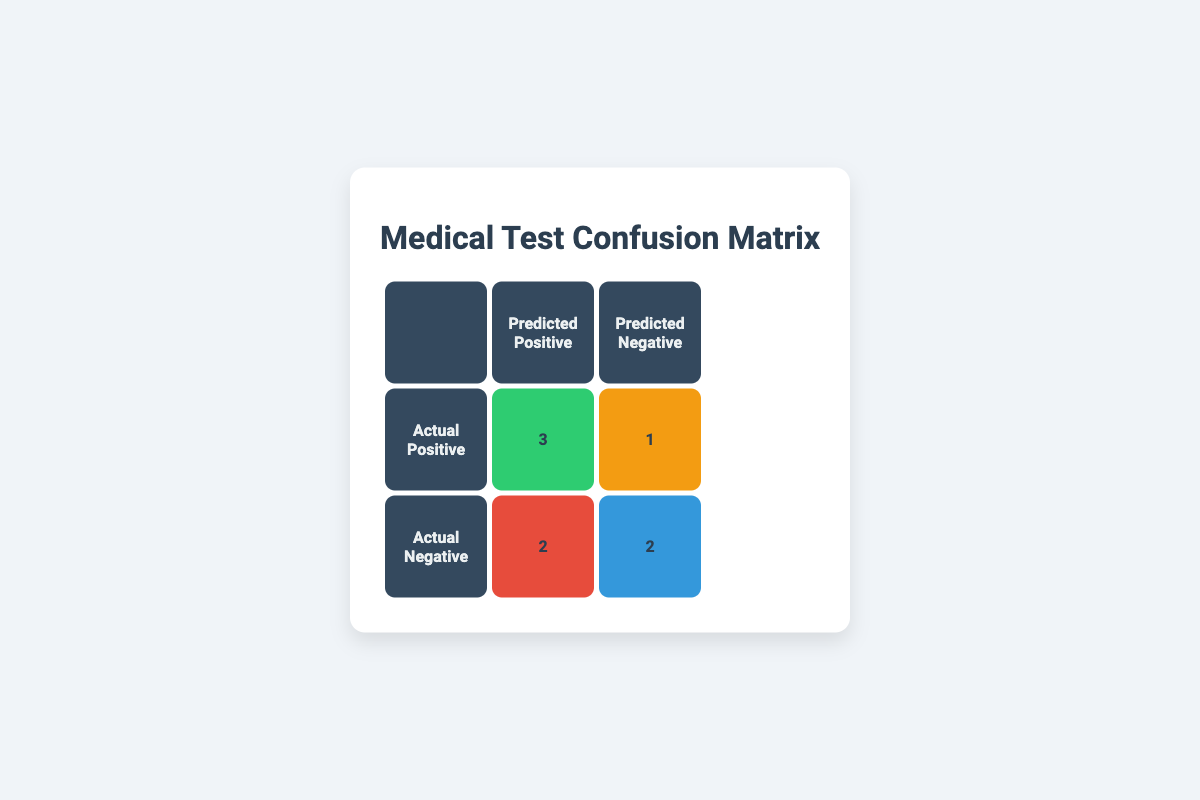What is the number of true positives? The table indicates that the true positives (actual positive and predicted positive) are represented in the first row and first column, which shows the value "3".
Answer: 3 What is the number of false negatives? The false negatives (actual positive and predicted negative) are found in the first row and second column. The value shown here is "1".
Answer: 1 How many total positive test results were predicted by the diagnostic test? The total positive predictions consist of true positives and false positives. From the table, true positives are "3" and false positives are "2". Adding these gives 3 + 2 = 5.
Answer: 5 Is the number of true negatives greater than the number of false positives? The true negatives are indicated in the second row and second column with a value of "2", while the false positives are in the second row and first column with a value of "2". Since 2 is not greater than 2, the answer is no.
Answer: No What is the total number of patients in the study? The total number of patients can be calculated by adding all entries in the matrix. There are 3 true positives, 1 false negative, 2 false positives, and 2 true negatives: 3 + 1 + 2 + 2 = 8.
Answer: 8 If only false positive results were addressed, how many true cases were missed? The total number of missed true cases corresponds to the false negatives (1) since they are patients who actually have the condition but tested negative.
Answer: 1 What proportion of patients tested negative actually had the disease? The actual negative patients who had the disease correspond to false negatives. There are 1 false negative and 2 true negatives making the total actual negatives equal to 3. Thus, the proportion is 1/3 which is approximately 0.33 or 33%.
Answer: 33% What is the difference between true positives and true negatives? The number of true positives is "3" and the number of true negatives is "2". The difference is calculated as 3 - 2 which equals 1.
Answer: 1 How many patients tested positive but did not have the disease? This value is represented by false positives in the table. According to the confusion matrix, there are "2" patients who tested positive but are actually negative.
Answer: 2 